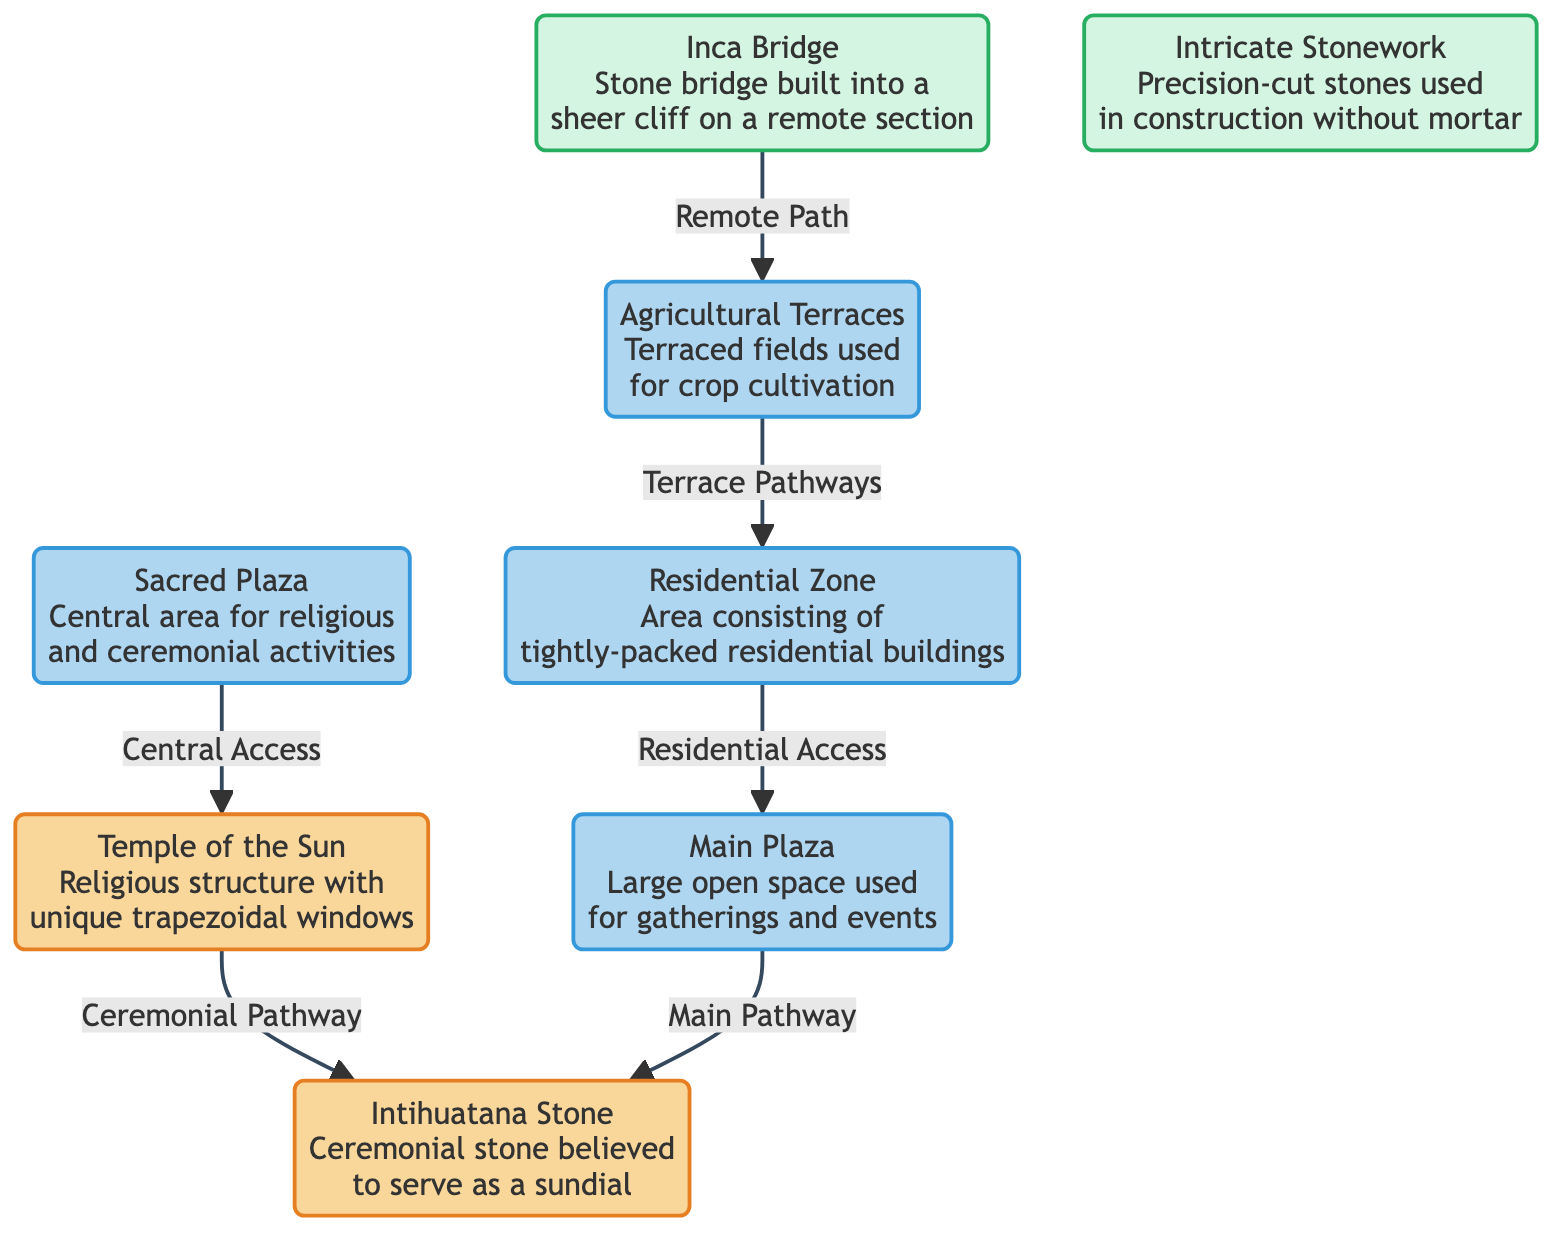What is the main access to the Temple of the Sun? The diagram indicates that the Sacred Plaza provides the central access pathway to the Temple of the Sun. This is shown by the directional arrow connecting Sacred Plaza to Temple of the Sun.
Answer: Sacred Plaza How many main areas are indicated in the diagram? The diagram visually categorizes the area into four main sections: Temple of the Sun, Sacred Plaza, Residential Zone, and Agricultural Terraces. Each of these areas is distinct and labeled, leading to a total count of four areas.
Answer: 4 Which structure is linked to the Agricultural Terraces? The diagram shows that the Residential Zone is connected to the Agricultural Terraces through the terrace pathways. This linkage is specified by the arrow connecting the two structures.
Answer: Residential Zone What type of stone feature is mentioned in the diagram? The diagram highlights 'Intricate Stonework,' which refers to the precision-cut stones used in construction without mortar. This is a specific architectural feature noted in the diagram.
Answer: Intricate Stonework Where is the Inca Bridge located relative to the Agricultural Terraces? According to the diagram, the Inca Bridge exists on a remote path leading from the Agricultural Terraces. This relationship is depicted by a directional arrow that indicates access from the terrace area to the bridge.
Answer: Remote Path What is the purpose of the Intihuatana Stone? The diagram states that the Intihuatana Stone is a ceremonial stone believed to serve as a sundial. This feature is summarized next to the stone in the visual representation.
Answer: Ceremonial stone Which area serves as a central location for gatherings? The diagram identifies the Main Plaza as the large open space used for gatherings and events. This designation is clearly labeled and signifies its importance in the layout.
Answer: Main Plaza What connects the Sacred Plaza to the Temple of the Sun? The pathway connecting the Sacred Plaza to the Temple of the Sun is referred to as the 'Central Access' in the diagram. This pathway is visually represented by an arrow, indicating a direct link.
Answer: Central Access 